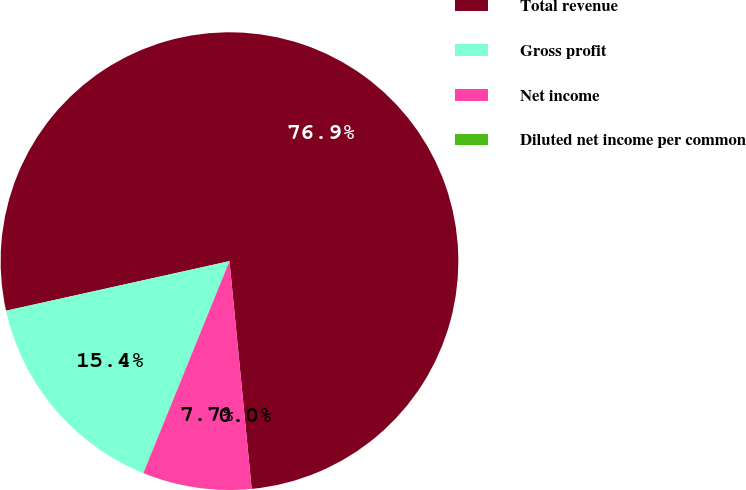<chart> <loc_0><loc_0><loc_500><loc_500><pie_chart><fcel>Total revenue<fcel>Gross profit<fcel>Net income<fcel>Diluted net income per common<nl><fcel>76.92%<fcel>15.38%<fcel>7.69%<fcel>0.0%<nl></chart> 